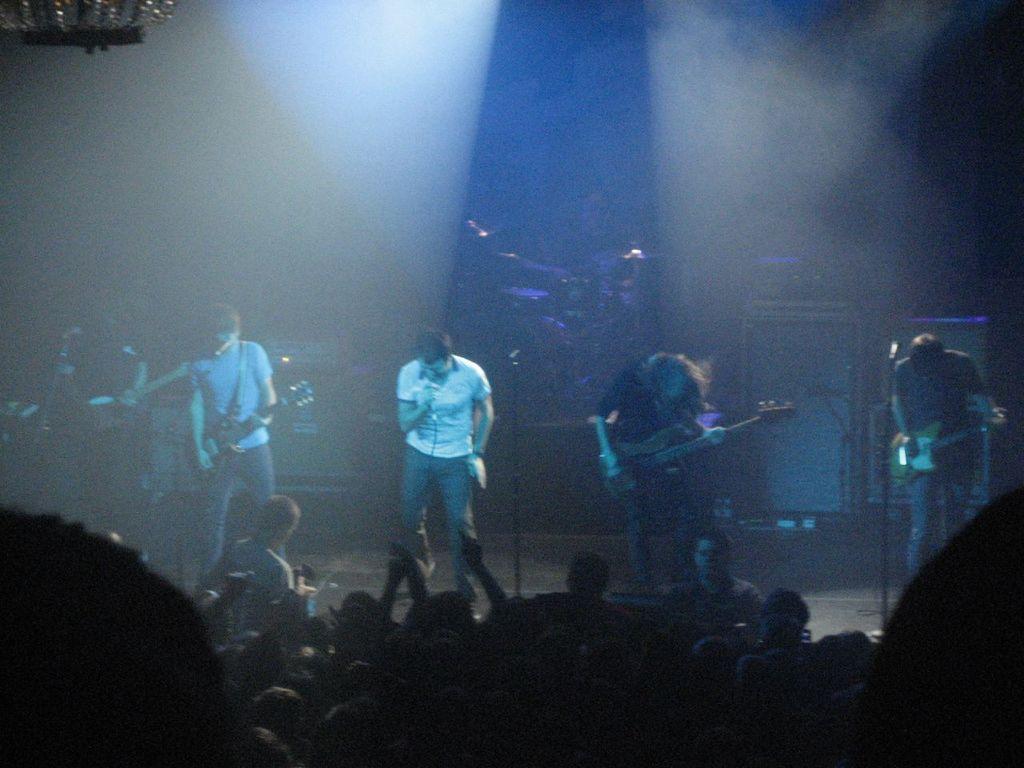Could you give a brief overview of what you see in this image? In this picture I can observe few people playing musical instruments on the stage. In the bottom of the picture I can observe audience. The background is dark. 